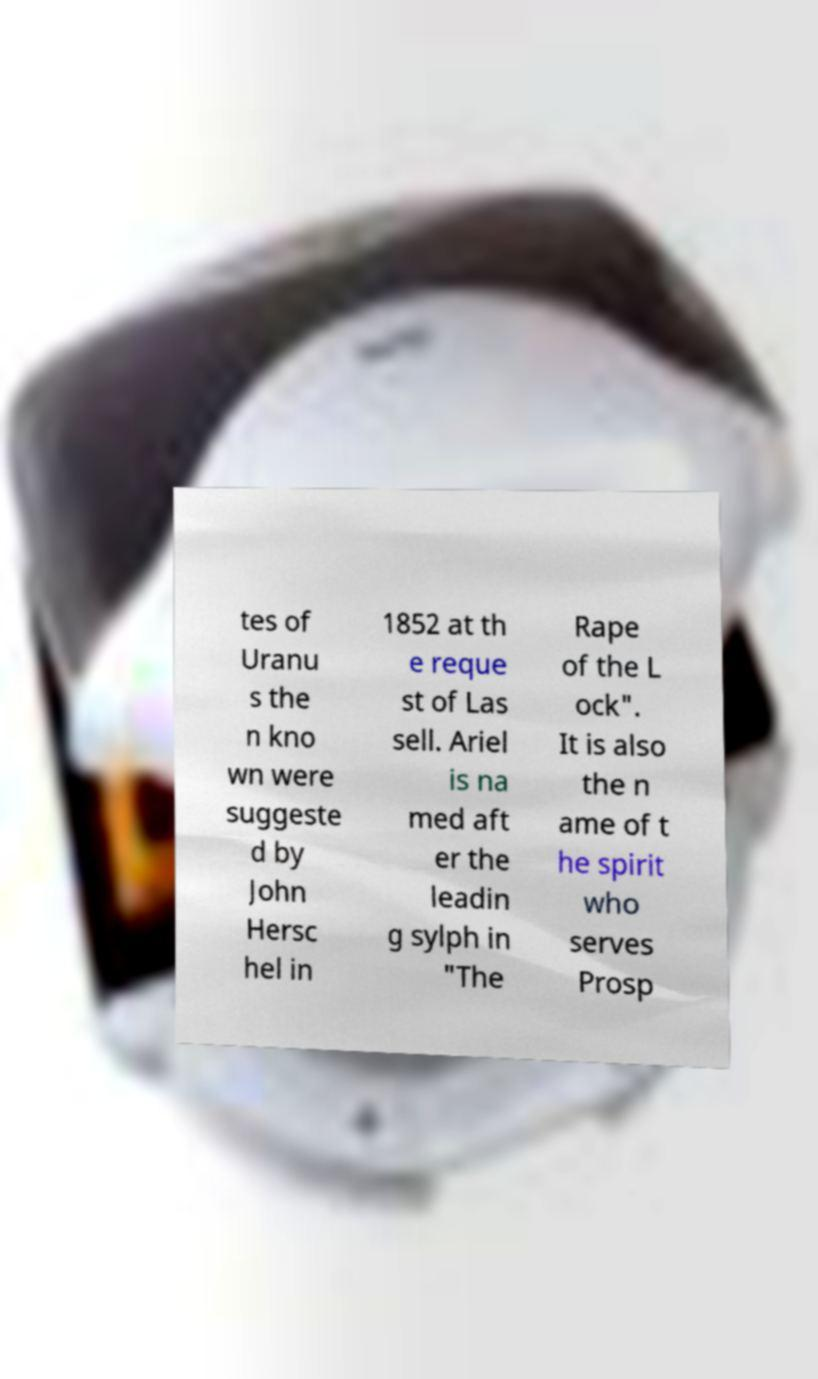What messages or text are displayed in this image? I need them in a readable, typed format. tes of Uranu s the n kno wn were suggeste d by John Hersc hel in 1852 at th e reque st of Las sell. Ariel is na med aft er the leadin g sylph in "The Rape of the L ock". It is also the n ame of t he spirit who serves Prosp 